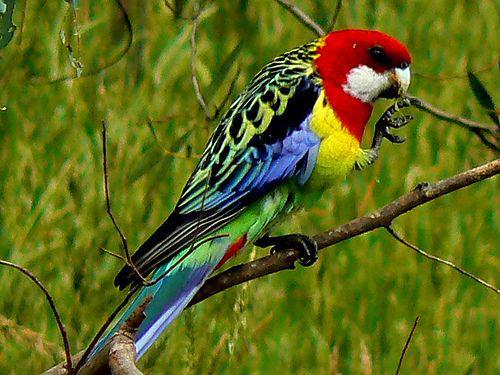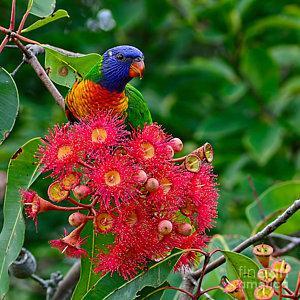The first image is the image on the left, the second image is the image on the right. Examine the images to the left and right. Is the description "Two birds share a branch in the image on the right." accurate? Answer yes or no. No. 